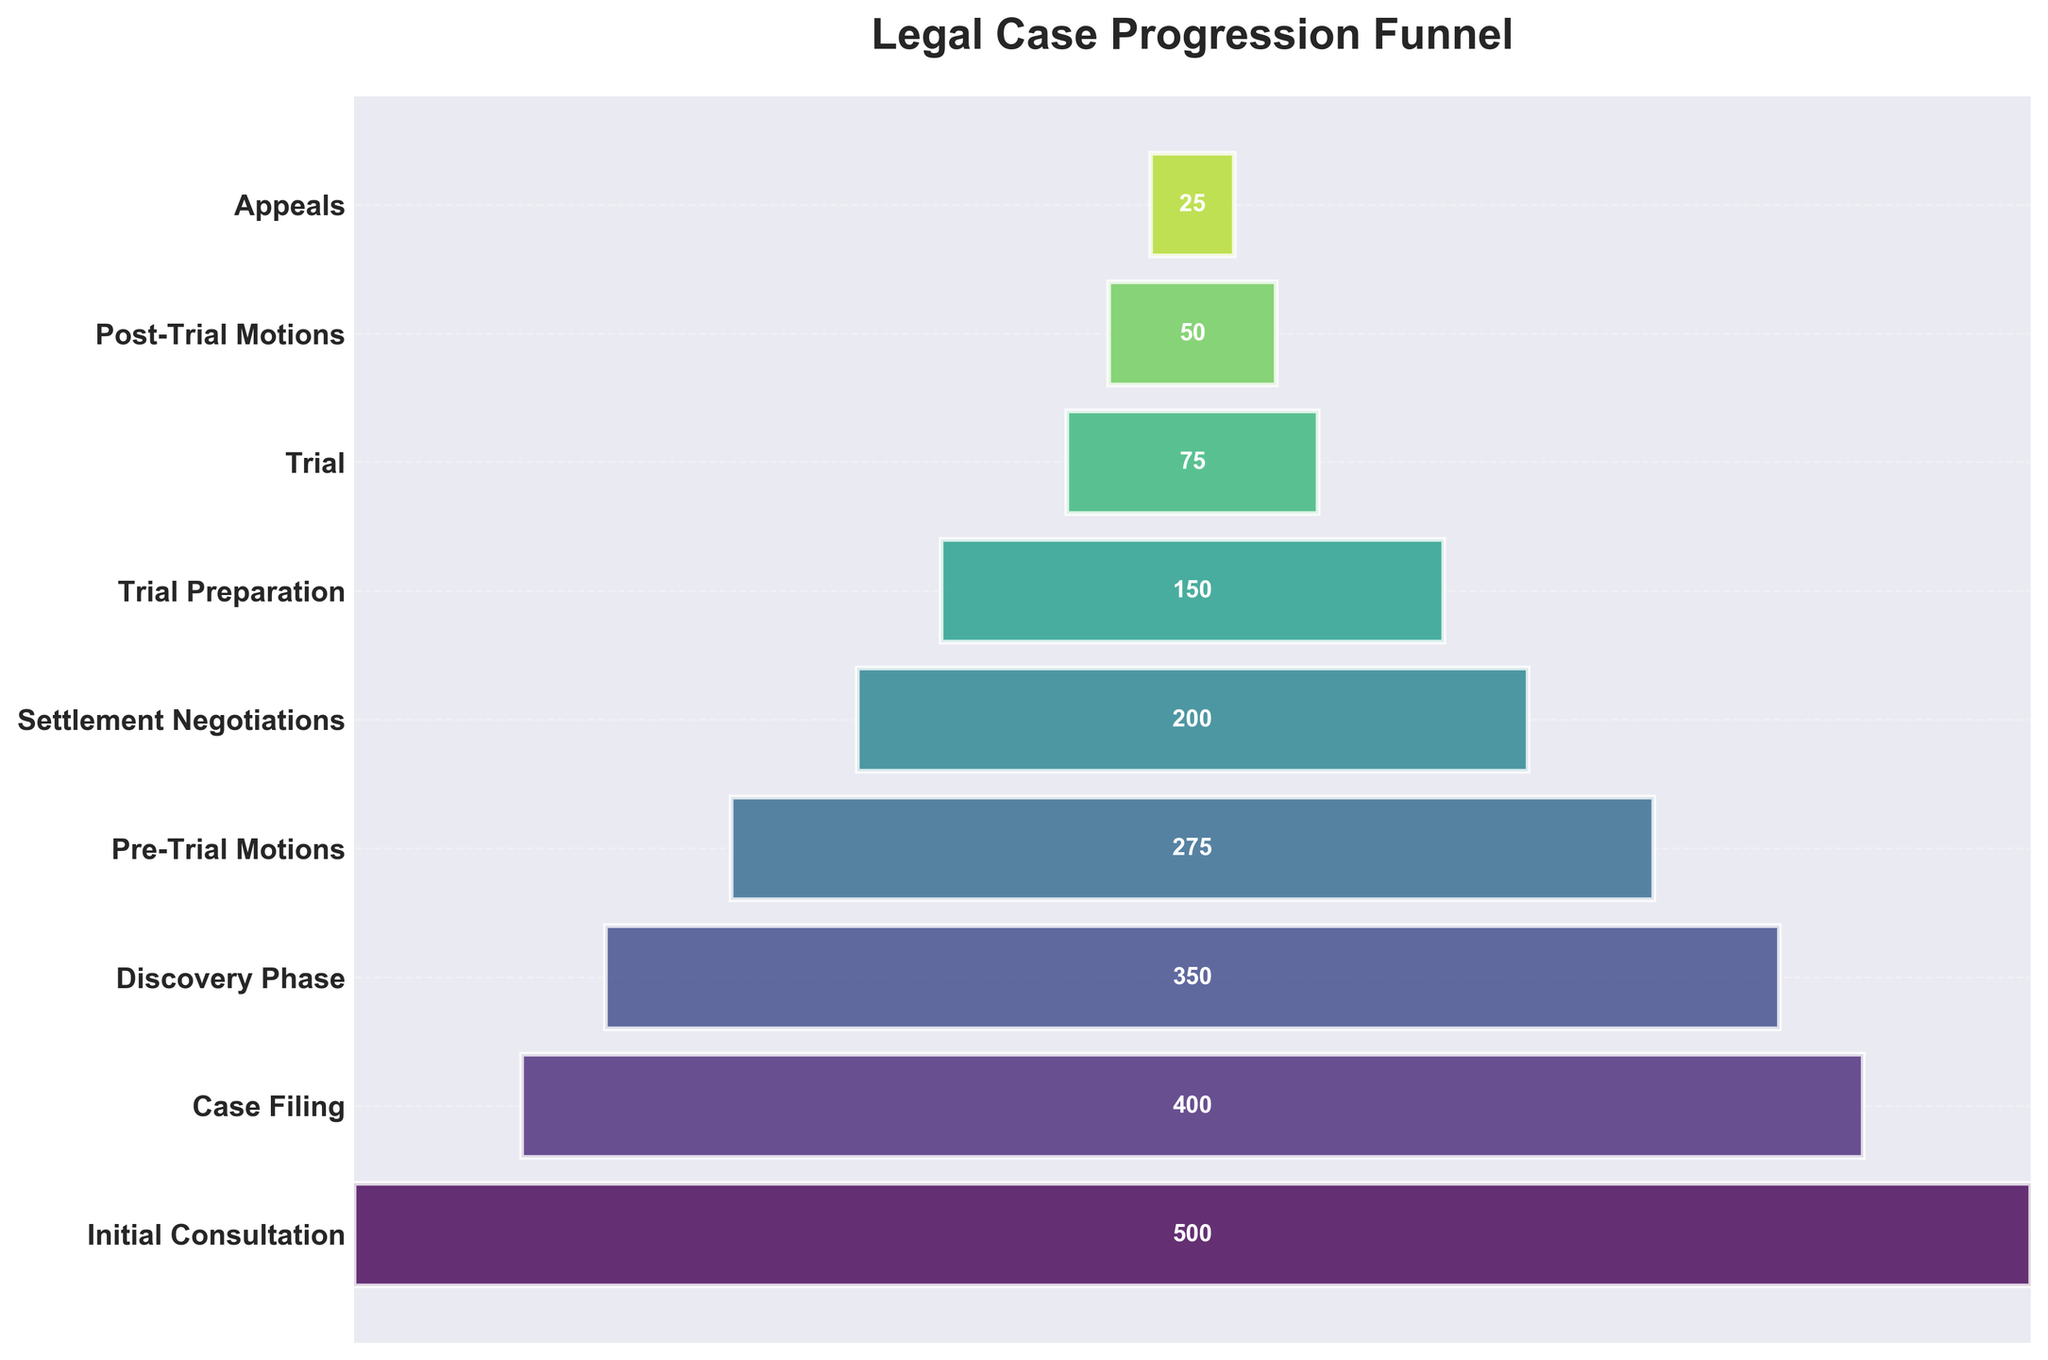What is the title of the funnel chart? The title of the chart is displayed at the top of the figure. From the given data and code, the title is "Legal Case Progression Funnel".
Answer: Legal Case Progression Funnel How many stages are there in total on the funnel chart? The chart lists each stage of the legal case process as a horizontal bar. By counting the number of horizontal bars in the funnel, we can determine the number of stages.
Answer: 9 What is the difference in the number of cases between Discovery Phase and Trial? The number of cases at the Discovery Phase is 350 and at Trial is 75. Subtract the number at Trial from the number at Discovery Phase (350 - 75).
Answer: 275 Which stage has the highest number of cases? The data shows the number of cases at each stage, and the widest bar represents the highest number of cases. Upon inspecting the given data, the Initial Consultation stage has the highest number with 500 cases.
Answer: Initial Consultation What percentage of cases reach the Appeals stage relative to the Initial Consultation stage? To determine the percentage, divide the number of cases at Appeals (25) by the number of cases at Initial Consultation (500), then multiply by 100. ((25 / 500) * 100)
Answer: 5% What is the average number of cases across all stages? Sum up the number of cases for all stages (500 + 400 + 350 + 275 + 200 + 150 + 75 + 50 + 25) = 2025, then divide by the number of stages (9). (2025 / 9)
Answer: 225 At which stage do the cases reduce by half or more compared to the initial stage? The Initial Consultation stage begins with 500 cases. Calculate half of this number (500 / 2 = 250) and identify the first stage where the number of cases drops to 250 or below. The Pre-Trial Motions stage has 275 cases, and the next stage, Settlement Negotiations, drops to 200 cases.
Answer: Settlement Negotiations How many cases are lost between the Pre-Trial Motions and the Trial Preparation stages? The number of cases is 275 at the Pre-Trial Motions stage and 150 at Trial Preparation. Subtract the number at Trial Preparation from Pre-Trial Motions (275 - 150).
Answer: 125 What is the total number of cases that go through the Settlement Negotiations and Appeals stages combined? Add the number of cases at Settlement Negotiations (200) and Appeals (25) together. (200 + 25)
Answer: 225 